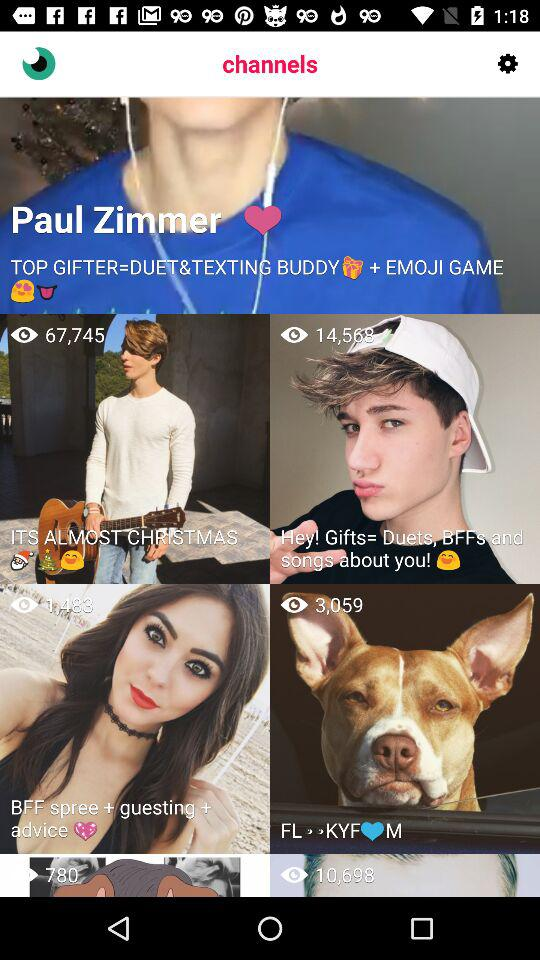What is the profile name? The profile name is Paul Zimmer. 